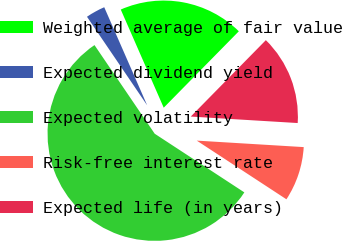Convert chart. <chart><loc_0><loc_0><loc_500><loc_500><pie_chart><fcel>Weighted average of fair value<fcel>Expected dividend yield<fcel>Expected volatility<fcel>Risk-free interest rate<fcel>Expected life (in years)<nl><fcel>18.93%<fcel>2.93%<fcel>56.28%<fcel>8.26%<fcel>13.6%<nl></chart> 